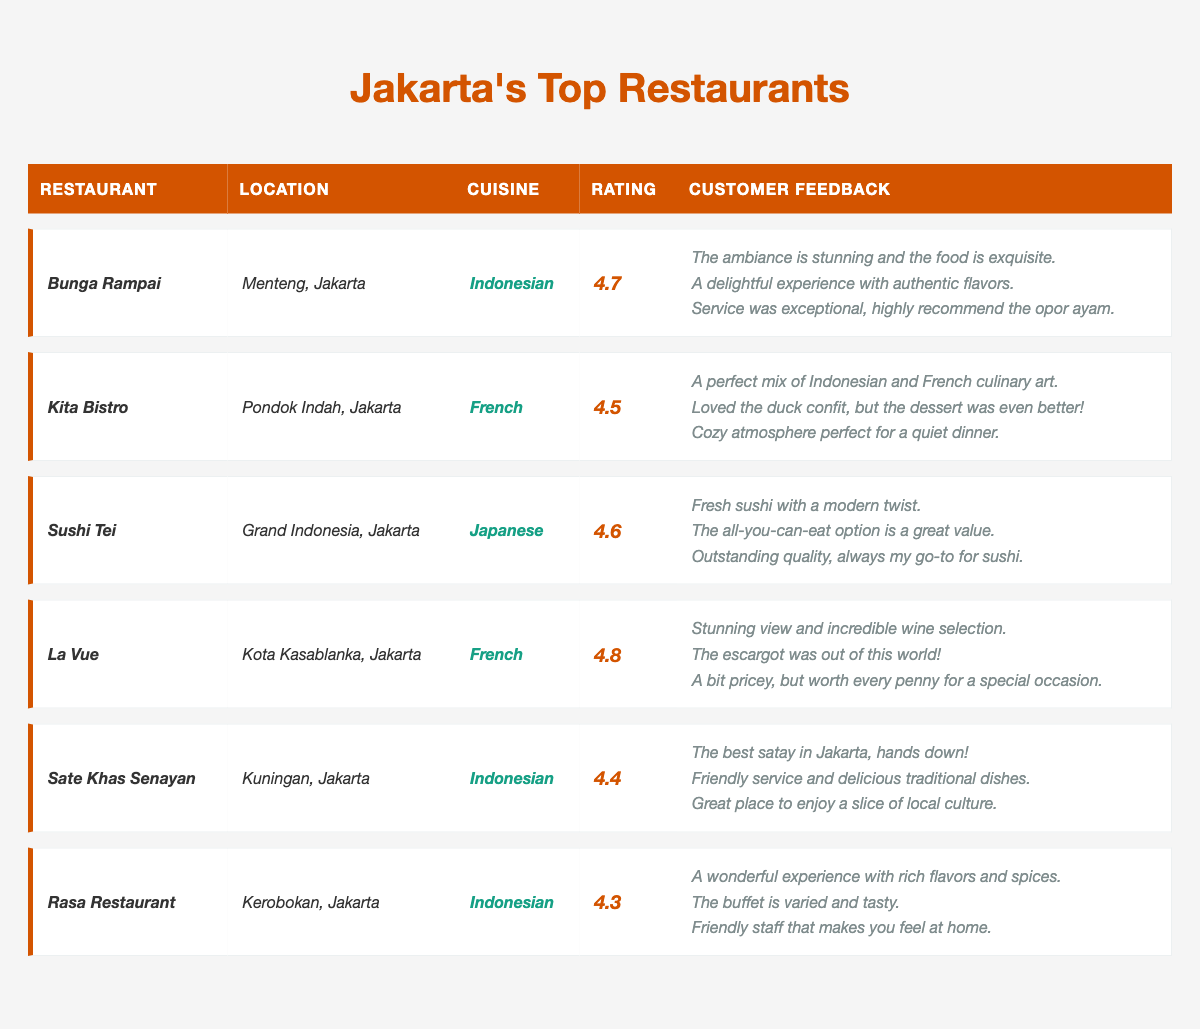What is the highest rated restaurant in Jakarta according to the table? By examining the "Rating" column in the table, "La Vue" has the highest rating of 4.8, which is greater than all other restaurants listed.
Answer: La Vue How many Indonesian restaurants are listed in the table? The restaurants labeled as Indonesian are Bunga Rampai, Sate Khas Senayan, and Rasa Restaurant. Counting these, there are three Indonesian restaurants in total.
Answer: 3 Which restaurant has the lowest rating? Comparing all the ratings, Rasa Restaurant has the lowest rating of 4.3, which is less than the ratings for the other restaurants.
Answer: Rasa Restaurant Is the "Escargot" dish mentioned in the feedback for La Vue? Yes, the feedback for La Vue explicitly mentions that "The escargot was out of this world!" indicating that the dish is indeed featured in customer feedback.
Answer: Yes What average rating do the Indonesian restaurants have? The ratings for Indonesian restaurants are: 4.7 (Bunga Rampai), 4.4 (Sate Khas Senayan) and 4.3 (Rasa Restaurant). Summing these: 4.7 + 4.4 + 4.3 = 13.4. To find the average, we divide by 3 (the number of Indonesian restaurants), which is 13.4 / 3 = 4.47.
Answer: 4.47 Which restaurant has the best customer feedback? "La Vue" has the most impressive feedback, highlighting the stunning view, incredible wine selection, and incredible escargot, suggesting an exceptional customer experience.
Answer: La Vue Are there any restaurants with a rating above 4.5? Yes, Bunga Rampai (4.7), Sushi Tei (4.6), and La Vue (4.8) all have ratings exceeding 4.5, confirming that multiple restaurants meet this criterion.
Answer: Yes What is the median rating of all the listed restaurants? The ratings are: 4.3, 4.4, 4.5, 4.6, 4.7, 4.8. Arranging them in order, the two middle values are 4.5 and 4.6. The median is calculated as (4.5 + 4.6) / 2 = 4.55.
Answer: 4.55 Which restaurant is located in Kota Kasablanka? According to the table, "La Vue" is the restaurant located in Kota Kasablanka, Jakarta.
Answer: La Vue What type of cuisine does Kita Bistro offer? The table specifies that Kita Bistro serves French cuisine, which categorizes it clearly within that culinary style.
Answer: French 